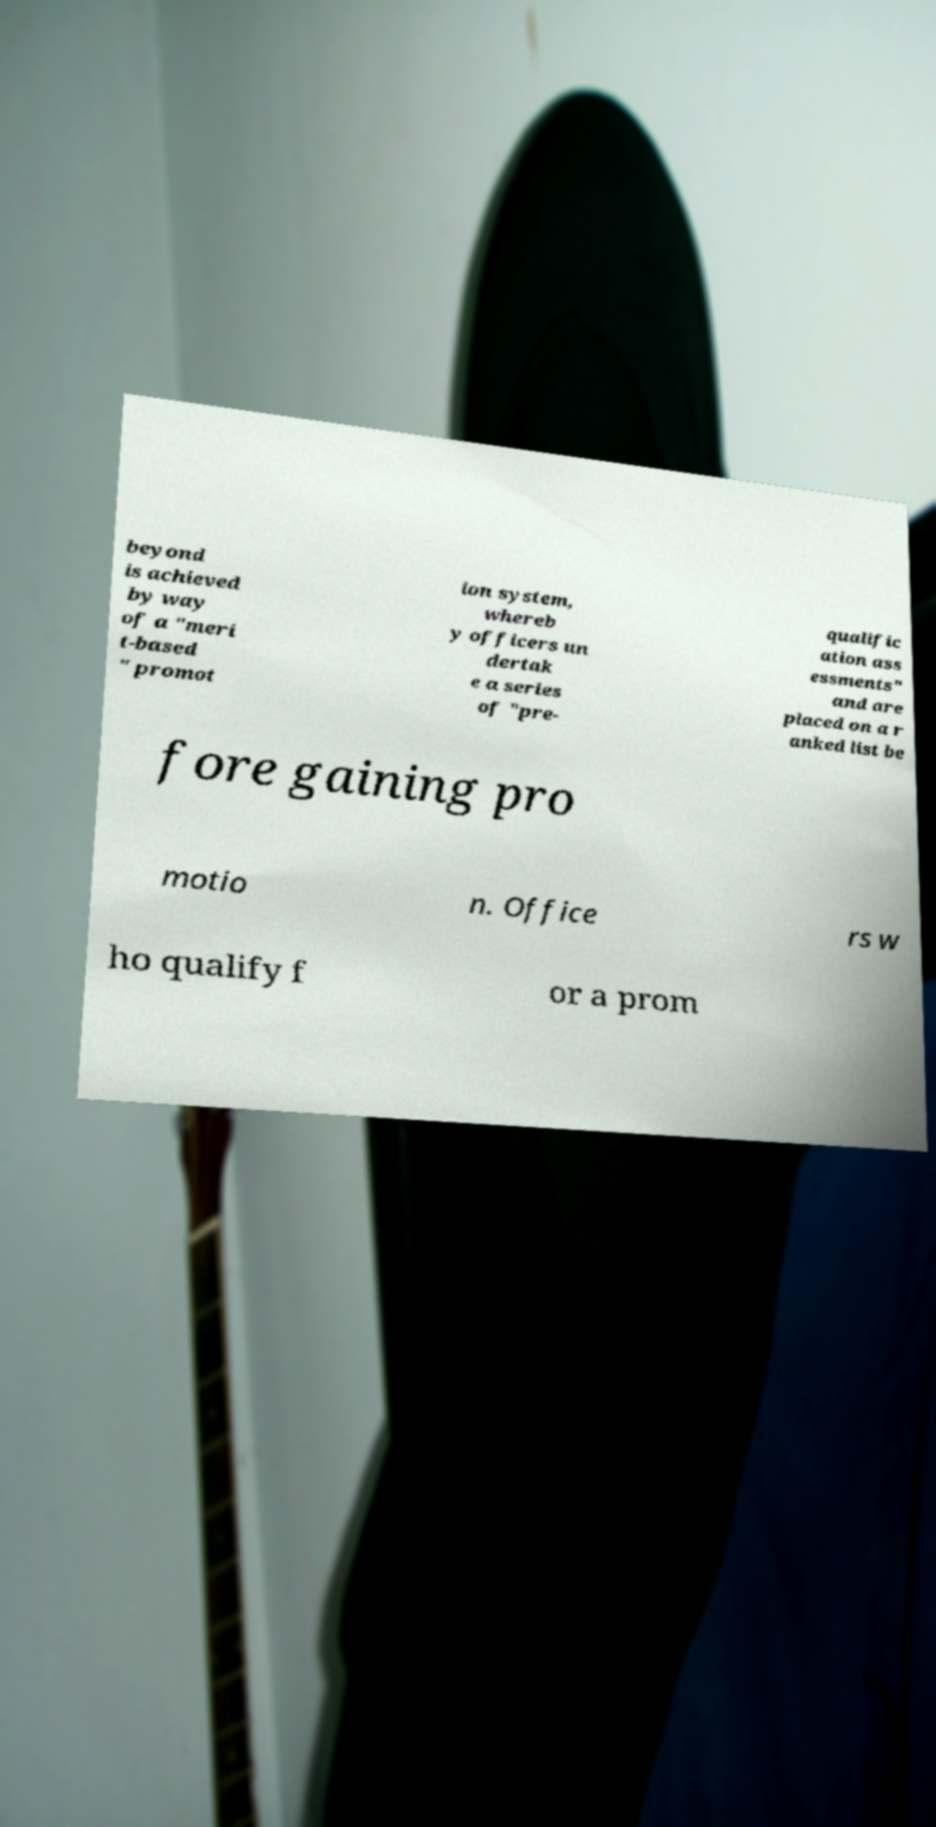Please read and relay the text visible in this image. What does it say? beyond is achieved by way of a "meri t-based " promot ion system, whereb y officers un dertak e a series of "pre- qualific ation ass essments" and are placed on a r anked list be fore gaining pro motio n. Office rs w ho qualify f or a prom 